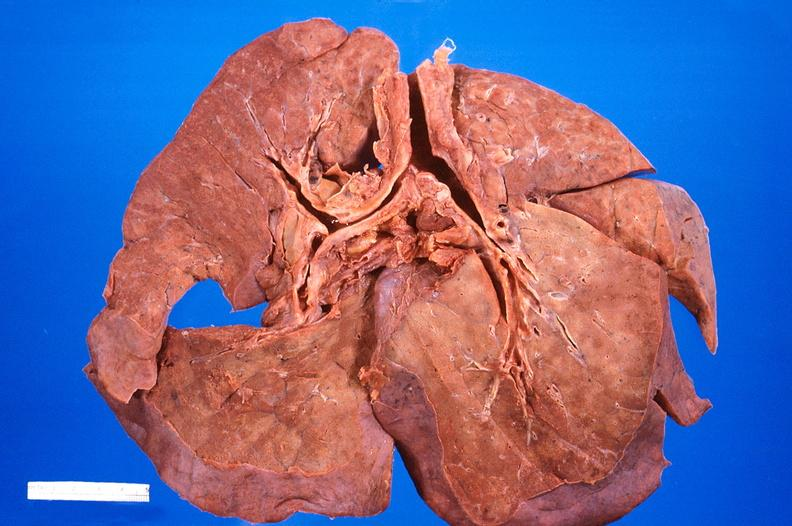s respiratory present?
Answer the question using a single word or phrase. Yes 